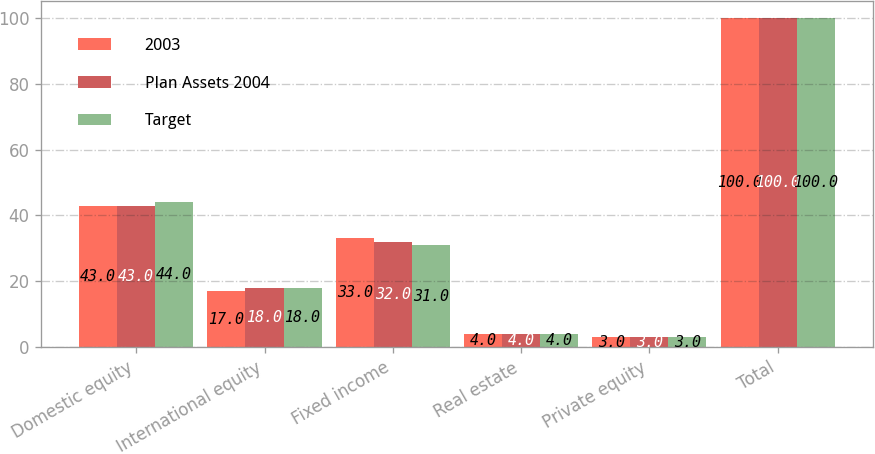<chart> <loc_0><loc_0><loc_500><loc_500><stacked_bar_chart><ecel><fcel>Domestic equity<fcel>International equity<fcel>Fixed income<fcel>Real estate<fcel>Private equity<fcel>Total<nl><fcel>2003<fcel>43<fcel>17<fcel>33<fcel>4<fcel>3<fcel>100<nl><fcel>Plan Assets 2004<fcel>43<fcel>18<fcel>32<fcel>4<fcel>3<fcel>100<nl><fcel>Target<fcel>44<fcel>18<fcel>31<fcel>4<fcel>3<fcel>100<nl></chart> 